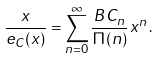<formula> <loc_0><loc_0><loc_500><loc_500>\frac { x } { e _ { C } ( x ) } = \sum _ { n = 0 } ^ { \infty } \frac { B C _ { n } } { \Pi ( n ) } x ^ { n } \, .</formula> 